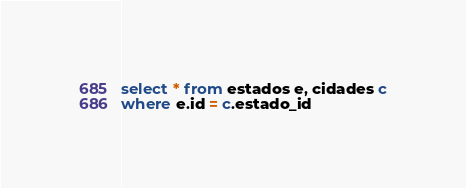<code> <loc_0><loc_0><loc_500><loc_500><_SQL_>select * from estados e, cidades c
where e.id = c.estado_id</code> 